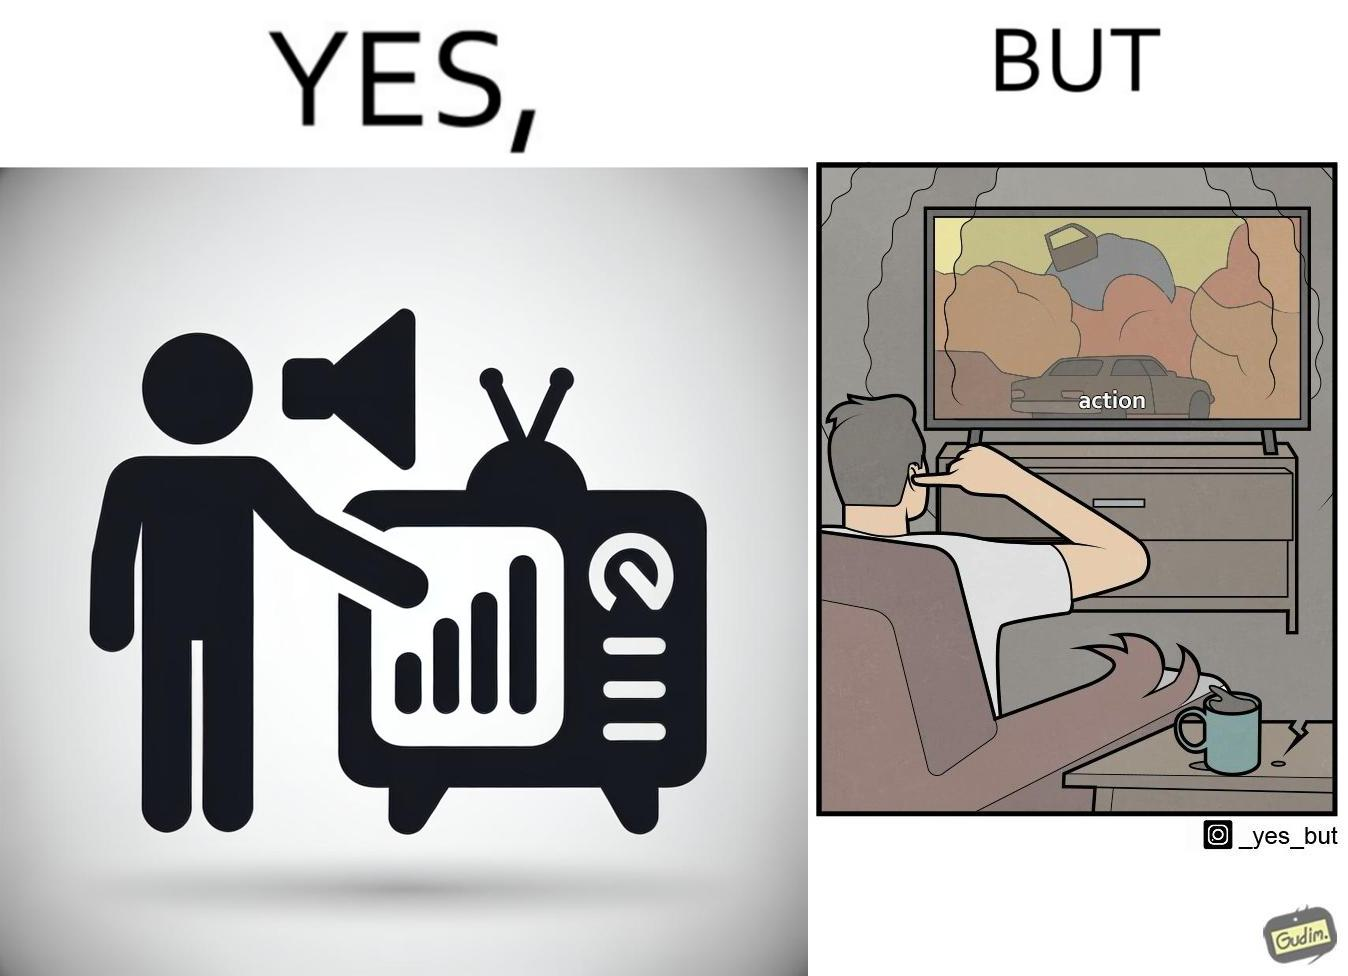Provide a description of this image. The action scenes of the movies or TV programs are mostly low in sound and people aren't able to hear them properly but in the action scenes due to the background music and other noise the sound becomes unbearable to some peoples 